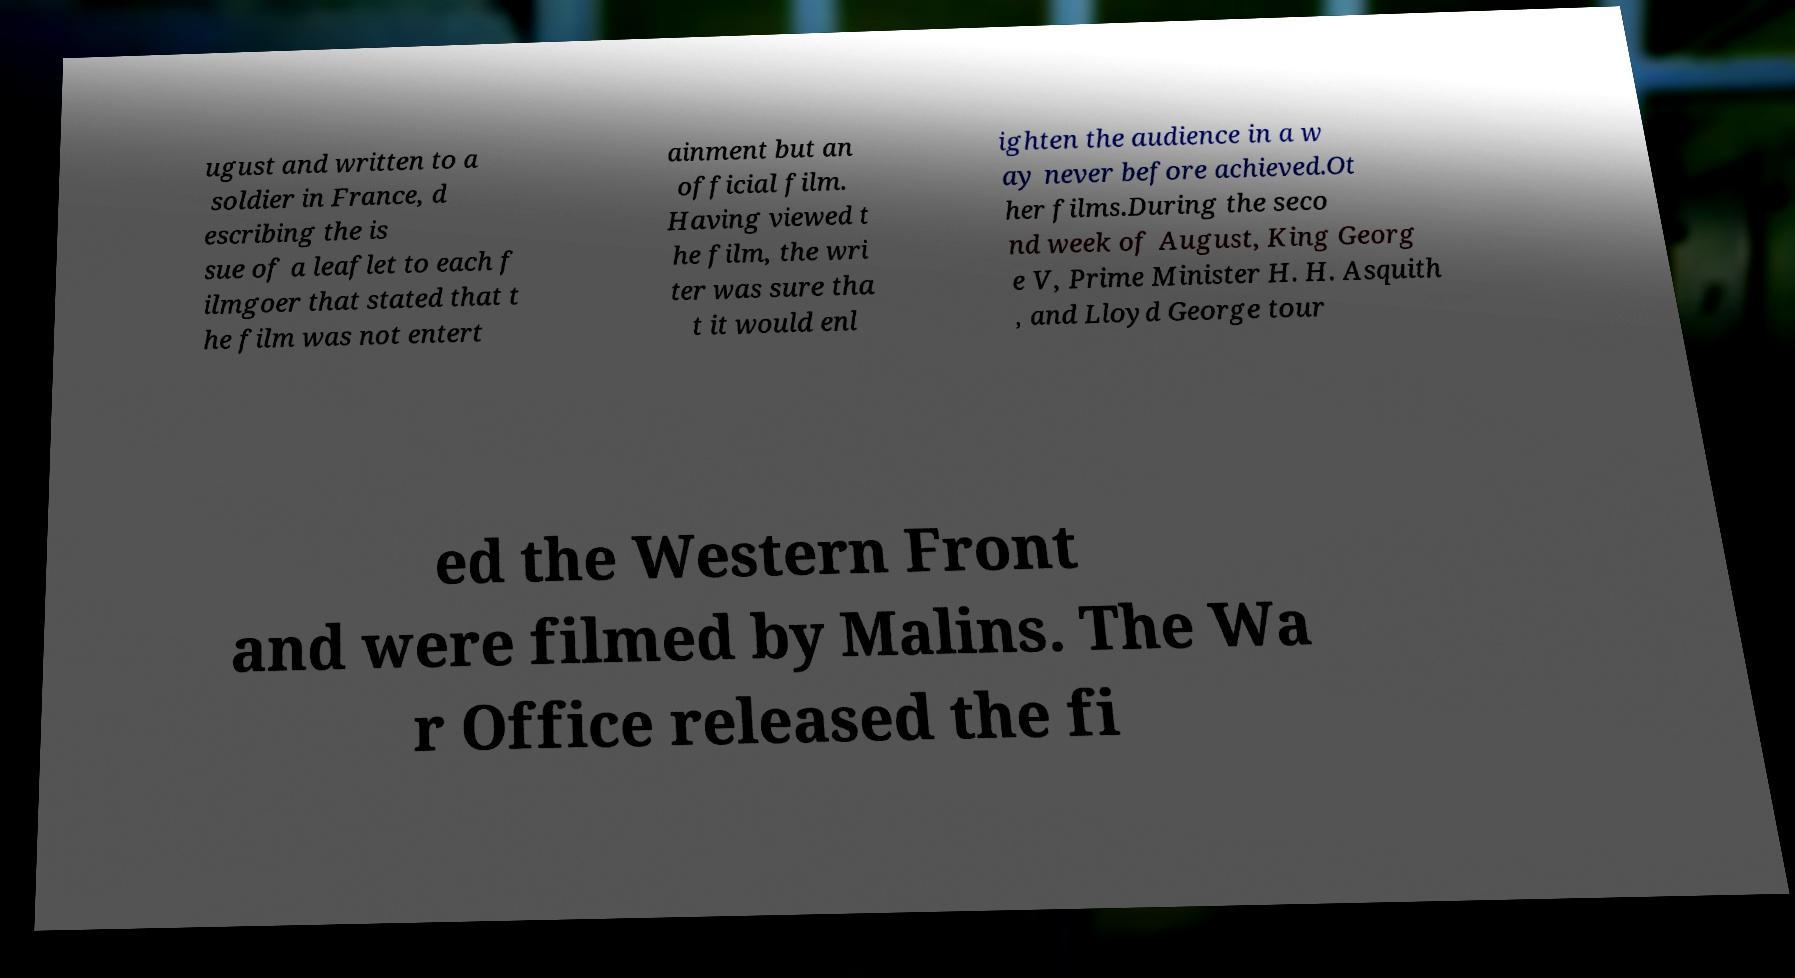I need the written content from this picture converted into text. Can you do that? ugust and written to a soldier in France, d escribing the is sue of a leaflet to each f ilmgoer that stated that t he film was not entert ainment but an official film. Having viewed t he film, the wri ter was sure tha t it would enl ighten the audience in a w ay never before achieved.Ot her films.During the seco nd week of August, King Georg e V, Prime Minister H. H. Asquith , and Lloyd George tour ed the Western Front and were filmed by Malins. The Wa r Office released the fi 